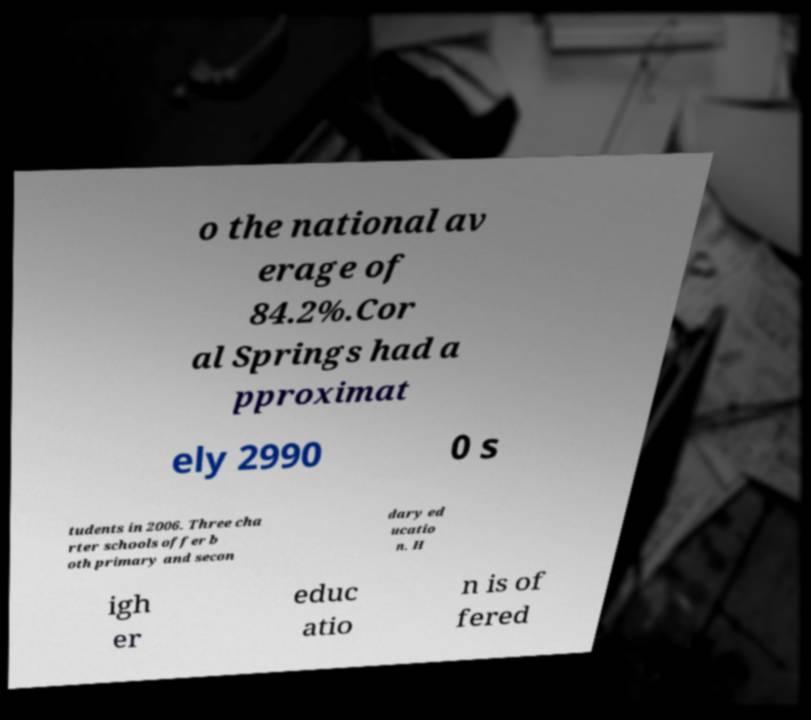Please read and relay the text visible in this image. What does it say? o the national av erage of 84.2%.Cor al Springs had a pproximat ely 2990 0 s tudents in 2006. Three cha rter schools offer b oth primary and secon dary ed ucatio n. H igh er educ atio n is of fered 